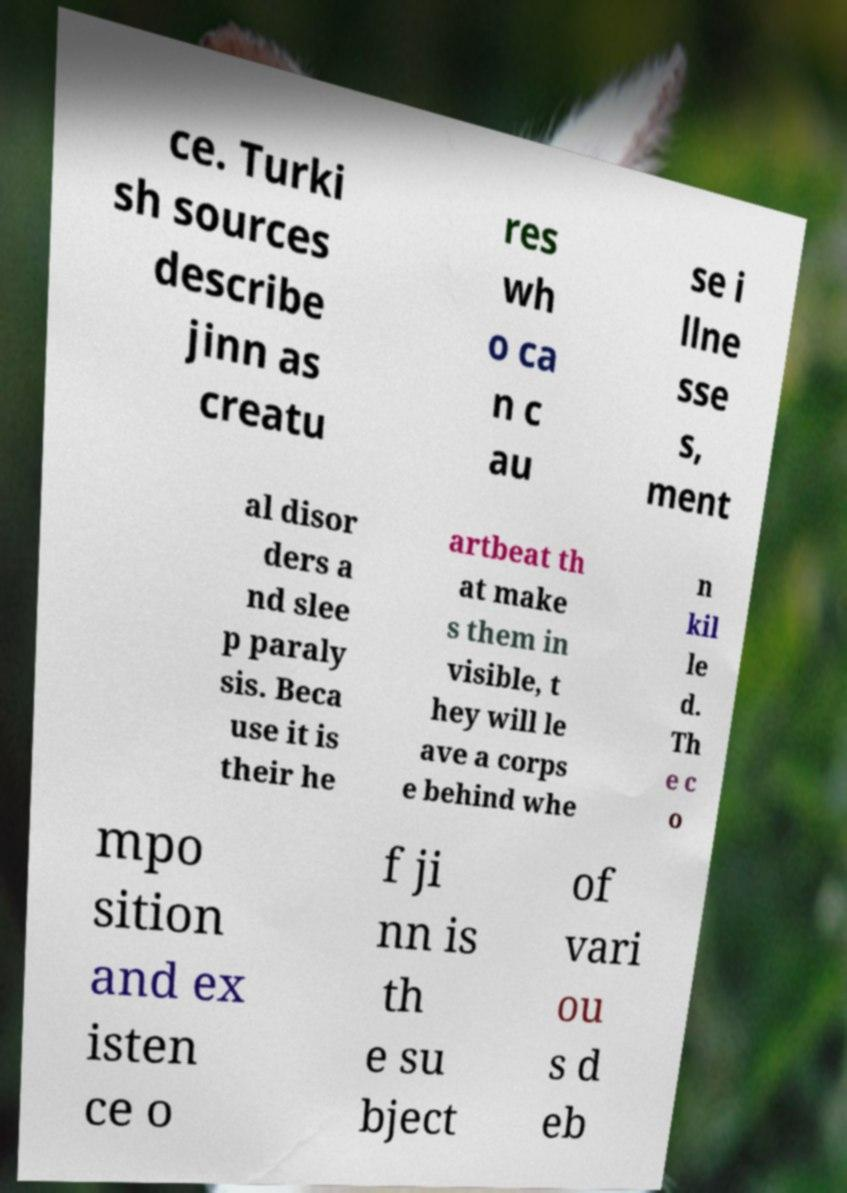Please read and relay the text visible in this image. What does it say? ce. Turki sh sources describe jinn as creatu res wh o ca n c au se i llne sse s, ment al disor ders a nd slee p paraly sis. Beca use it is their he artbeat th at make s them in visible, t hey will le ave a corps e behind whe n kil le d. Th e c o mpo sition and ex isten ce o f ji nn is th e su bject of vari ou s d eb 